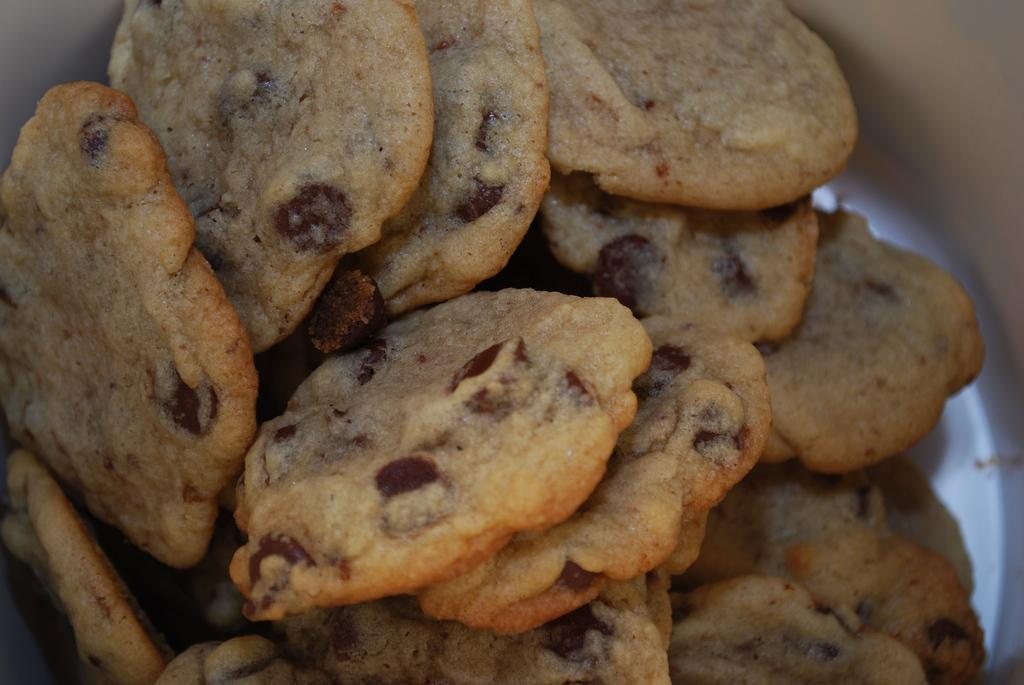What type of food can be seen in the image? There are cookies in the image. How are the cookies stored or contained? The cookies are in a box. What specific type of cookies are they? The cookies have chocolate chips on them. What type of underwear is visible in the image? There is no underwear present in the image; it features cookies in a box. Can you tell me how many kisses are on the cookies in the image? The cookies in the image have chocolate chips on them, not kisses. 